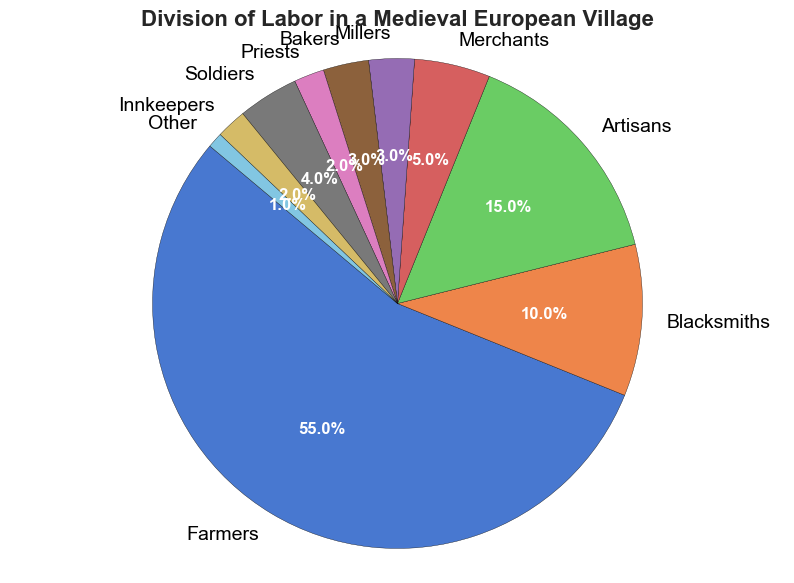What percentage of the population worked in occupations other than farming, blacksmithing, and artisanal crafts? Adding up the percentages of occupations other than Farmers (55%), Blacksmiths (10%), and Artisans (15%) gives 100 - (55 + 10 + 15) = 20%
Answer: 20% Which occupation has the smallest representation in the village? Look for the occupation with the smallest slice or the lowest percentage in the pie chart. The 'Other' category has the smallest percentage at 1%
Answer: Other How many occupations make up at least 5% of the village's labor force? Count the slices that have a percentage 5% or more: Farmers (55%), Blacksmiths (10%), Artisans (15%), Merchants (5%) which are 4 occupations
Answer: 4 What is the combined percentage of Millers and Bakers? Add the percentages of Millers (3%) and Bakers (3%) to get a combined percentage of 3 + 3 = 6%
Answer: 6% Are there more farmers than the combined percentage of blacksmiths, soldiers, and priests? Check if the percentage of Farmers (55%) is greater than the sum of Blacksmiths (10%), Soldiers (4%), and Priests (2%). 55 > (10 + 4 + 2) = 16
Answer: Yes Is the percentage of Artisans greater or less than the sum of Innkeepers and Soldiers? Compare the percentage of Artisans (15%) with the sum of Innkeepers (2%) and Soldiers (4%). 15 > (2 + 4) = 6
Answer: Greater Between Millers and Priests, who has a higher percentage, and what is the difference between them? Compare the percentages of Millers (3%) and Priests (2%). Millers have a higher percentage. The difference is 3 - 2 = 1
Answer: Millers, 1 If the Innkeepers and Priests are combined, what would their total percentage be? Add the percentages of Innkeepers (2%) and Priests (2%) to get a combined percentage of 2 + 2 = 4%
Answer: 4% What percentage do Soldiers and Bakers make up together? Sum the percentages of Soldiers (4%) and Bakers (3%) to get 4 + 3 = 7%
Answer: 7% Is the percentage of Merchants less than or equal to half of the percentage of Artisans? Check if the percentage of Merchants (5%) is less than or equal to half of Artisans (15%). 15/2 = 7.5, and 5 < 7.5, so the answer is yes
Answer: Yes 